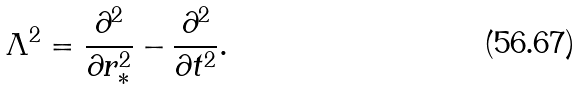<formula> <loc_0><loc_0><loc_500><loc_500>\Lambda ^ { 2 } = \frac { \partial ^ { 2 } } { \partial r _ { * } ^ { 2 } } - \frac { \partial ^ { 2 } } { \partial t ^ { 2 } } .</formula> 